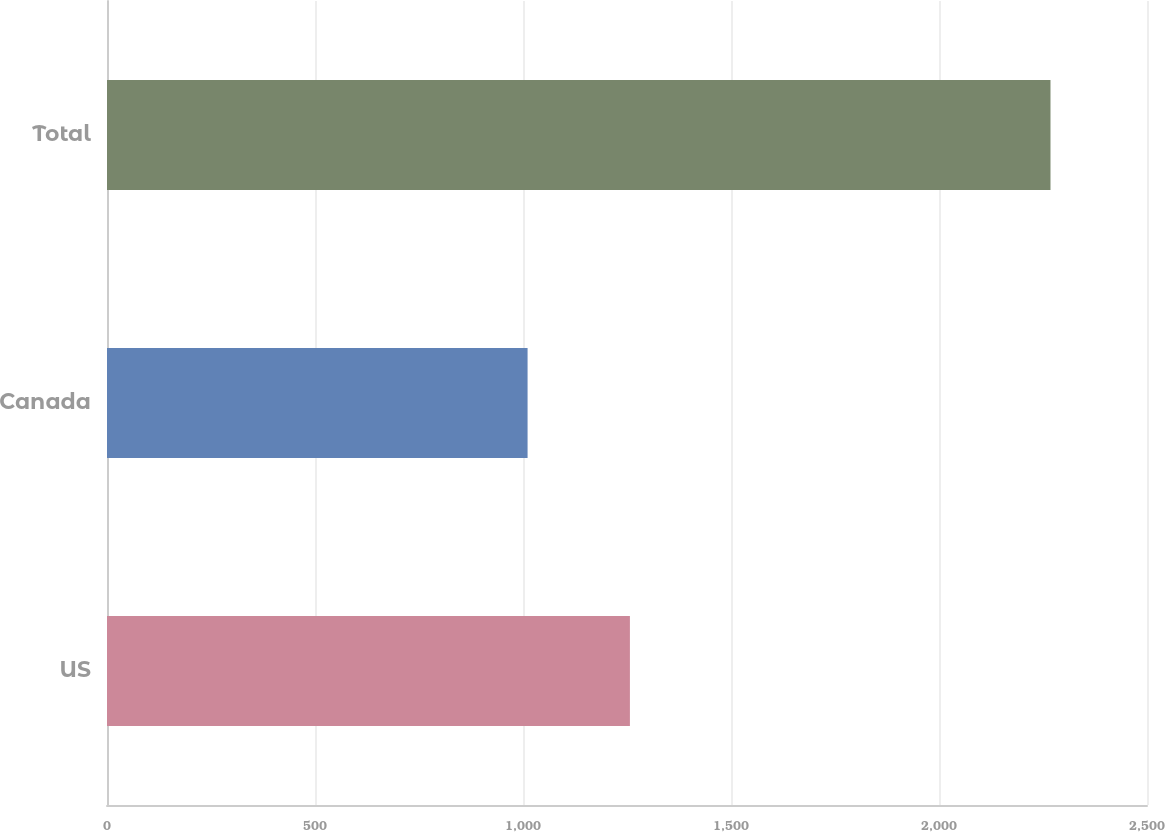Convert chart to OTSL. <chart><loc_0><loc_0><loc_500><loc_500><bar_chart><fcel>US<fcel>Canada<fcel>Total<nl><fcel>1257<fcel>1011<fcel>2268<nl></chart> 